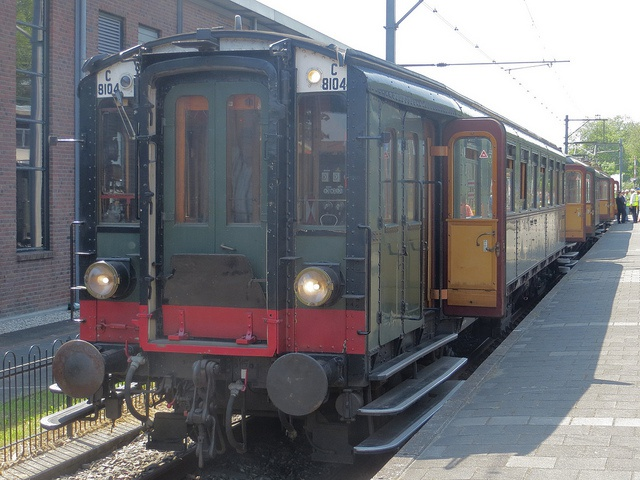Describe the objects in this image and their specific colors. I can see train in gray, black, and darkblue tones, people in gray and black tones, people in gray, black, and darkblue tones, people in gray, lightgray, darkgray, and black tones, and people in gray and darkgray tones in this image. 